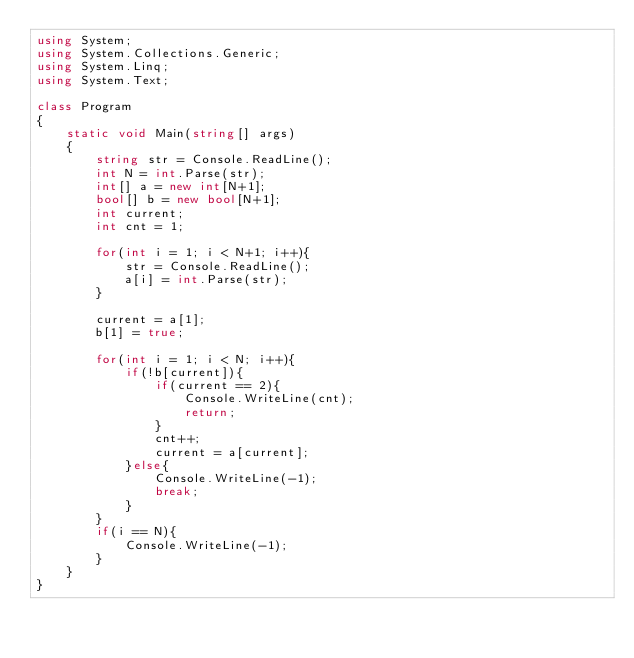<code> <loc_0><loc_0><loc_500><loc_500><_C#_>using System;
using System.Collections.Generic;
using System.Linq;
using System.Text;

class Program
{
    static void Main(string[] args)
    {
        string str = Console.ReadLine();
        int N = int.Parse(str);
        int[] a = new int[N+1];
        bool[] b = new bool[N+1];
        int current;
        int cnt = 1;

        for(int i = 1; i < N+1; i++){
            str = Console.ReadLine();
            a[i] = int.Parse(str);
        }

        current = a[1];
        b[1] = true;

        for(int i = 1; i < N; i++){
            if(!b[current]){
                if(current == 2){
                    Console.WriteLine(cnt);
                    return;
                }
                cnt++;
                current = a[current];
            }else{
                Console.WriteLine(-1);
                break;
            }
        }
        if(i == N){
            Console.WriteLine(-1);
        }
    }
}

</code> 